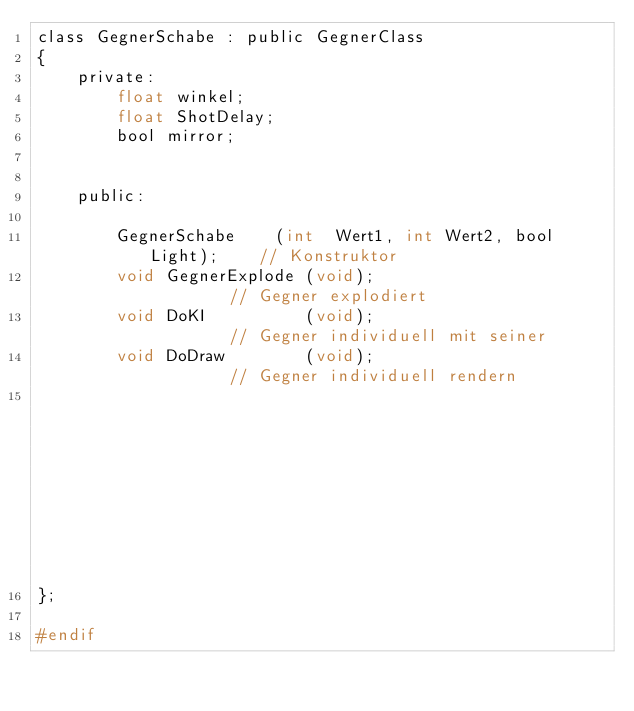Convert code to text. <code><loc_0><loc_0><loc_500><loc_500><_C_>class GegnerSchabe : public GegnerClass
{
	private:
		float winkel;
		float ShotDelay;
		bool mirror;


	public:

		GegnerSchabe	(int  Wert1, int Wert2, bool Light);	// Konstruktor					   
		void GegnerExplode (void);								// Gegner explodiert
		void DoKI		   (void);								// Gegner individuell mit seiner 
		void DoDraw		   (void);								// Gegner individuell rendern
															// eigenen kleinen KI bewegen
};

#endif
</code> 